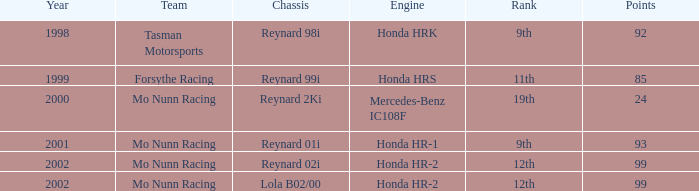What is the total number of points of the honda hr-1 engine? 1.0. 